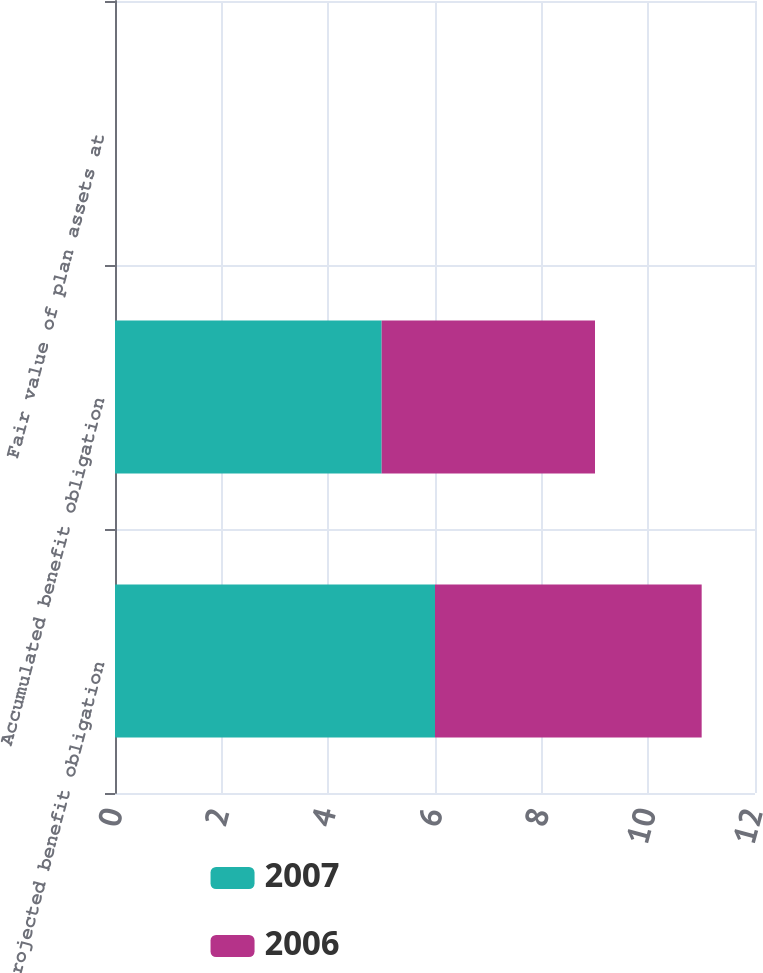Convert chart. <chart><loc_0><loc_0><loc_500><loc_500><stacked_bar_chart><ecel><fcel>Projected benefit obligation<fcel>Accumulated benefit obligation<fcel>Fair value of plan assets at<nl><fcel>2007<fcel>6<fcel>5<fcel>0<nl><fcel>2006<fcel>5<fcel>4<fcel>0<nl></chart> 